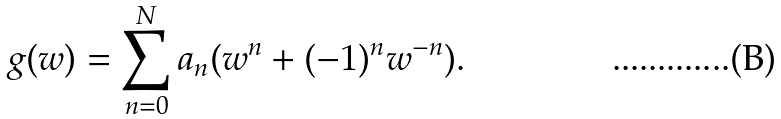Convert formula to latex. <formula><loc_0><loc_0><loc_500><loc_500>g ( w ) = \sum _ { n = 0 } ^ { N } a _ { n } ( w ^ { n } + ( - 1 ) ^ { n } w ^ { - n } ) .</formula> 